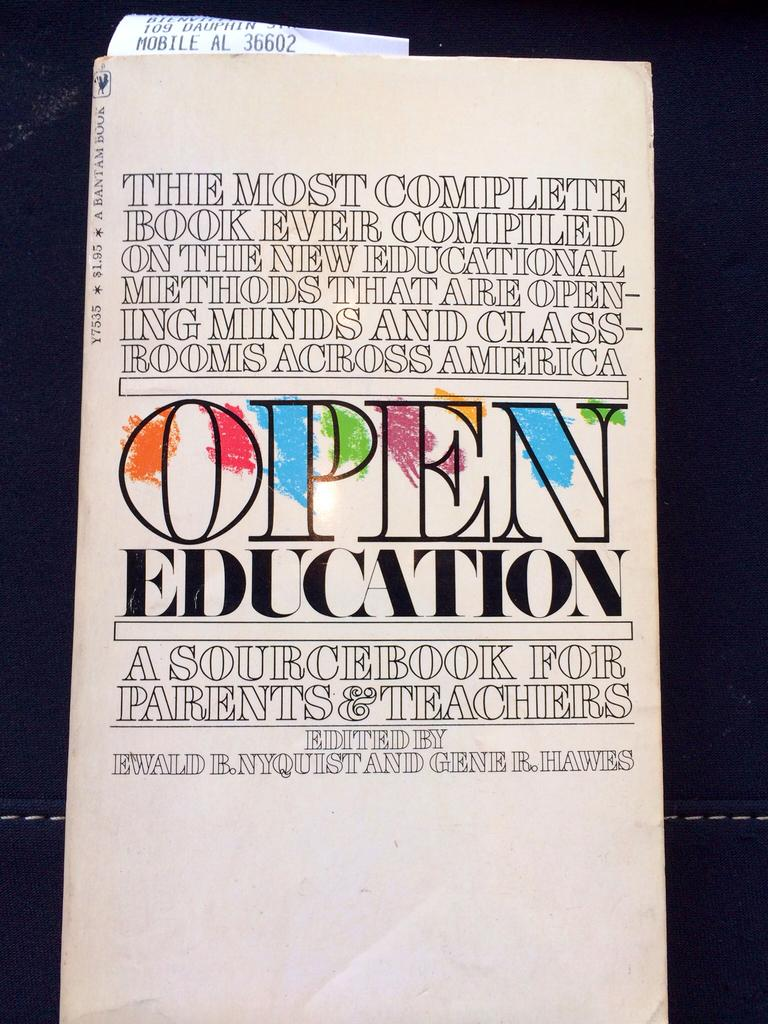Provide a one-sentence caption for the provided image. An book called Open Education, a sourcebook for parents and teachers. 